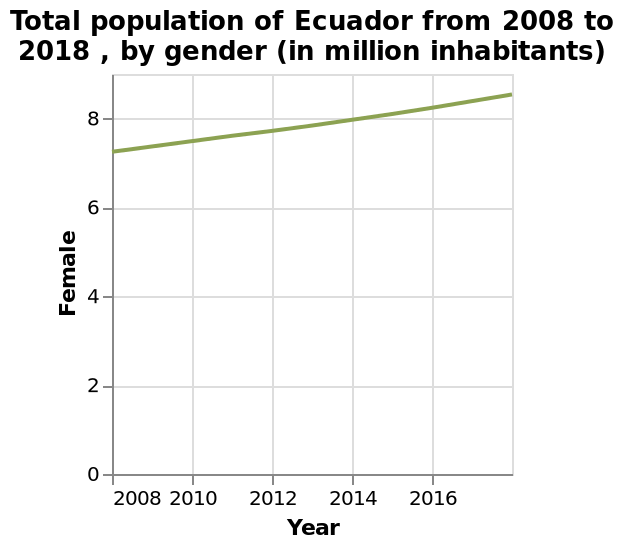<image>
What trend does the line chart of female population in Ecuador from 2008 to 2018 show?  The line chart shows a steady and strong increase in the female population of Ecuador from 2008 to 2018. What is the highest point on the line graph? The highest point on the line graph represents the peak of the Female population in Ecuador between 2008 and 2018. What was the overall trend of the female population in Ecuador from 2008 to 2018? The overall trend of the female population in Ecuador from 2008 to 2018 was a steady and strong increase. What can be inferred about the future population of females in Ecuador based on the trend shown in the line chart?  Based on the trend shown in the line chart, it can be inferred that the population of females in Ecuador will continue to grow at a steady pace in the coming years. Was the overall trend of the female population in Ecuador from 2008 to 2018 a steady and strong decrease? No.The overall trend of the female population in Ecuador from 2008 to 2018 was a steady and strong increase. 